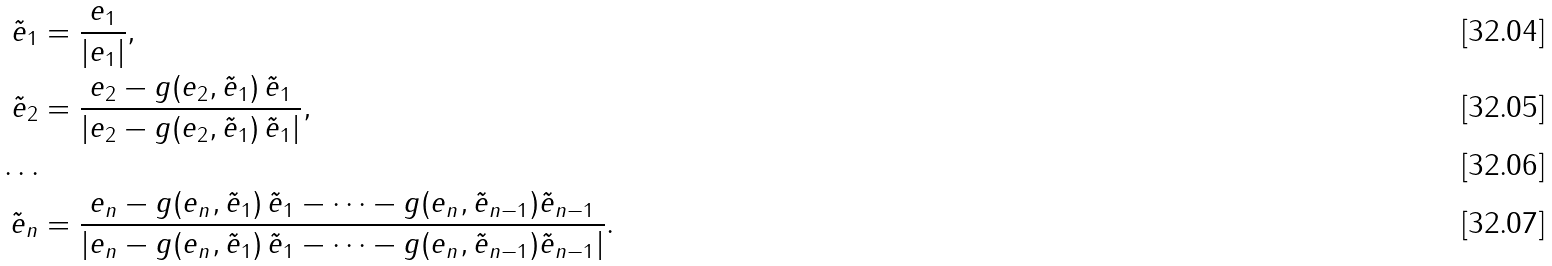<formula> <loc_0><loc_0><loc_500><loc_500>\tilde { e } _ { 1 } & = \frac { e _ { 1 } } { | e _ { 1 } | } , \\ \tilde { e } _ { 2 } & = \frac { e _ { 2 } - g ( e _ { 2 } , \tilde { e } _ { 1 } ) \, \tilde { e } _ { 1 } } { | e _ { 2 } - g ( e _ { 2 } , \tilde { e } _ { 1 } ) \, \tilde { e } _ { 1 } | } , \\ \dots \\ \tilde { e } _ { n } & = \frac { e _ { n } - g ( e _ { n } , \tilde { e } _ { 1 } ) \, \tilde { e } _ { 1 } - \dots - g ( e _ { n } , \tilde { e } _ { n - 1 } ) \tilde { e } _ { n - 1 } } { | e _ { n } - g ( e _ { n } , \tilde { e } _ { 1 } ) \, \tilde { e } _ { 1 } - \dots - g ( e _ { n } , \tilde { e } _ { n - 1 } ) \tilde { e } _ { n - 1 } | } .</formula> 